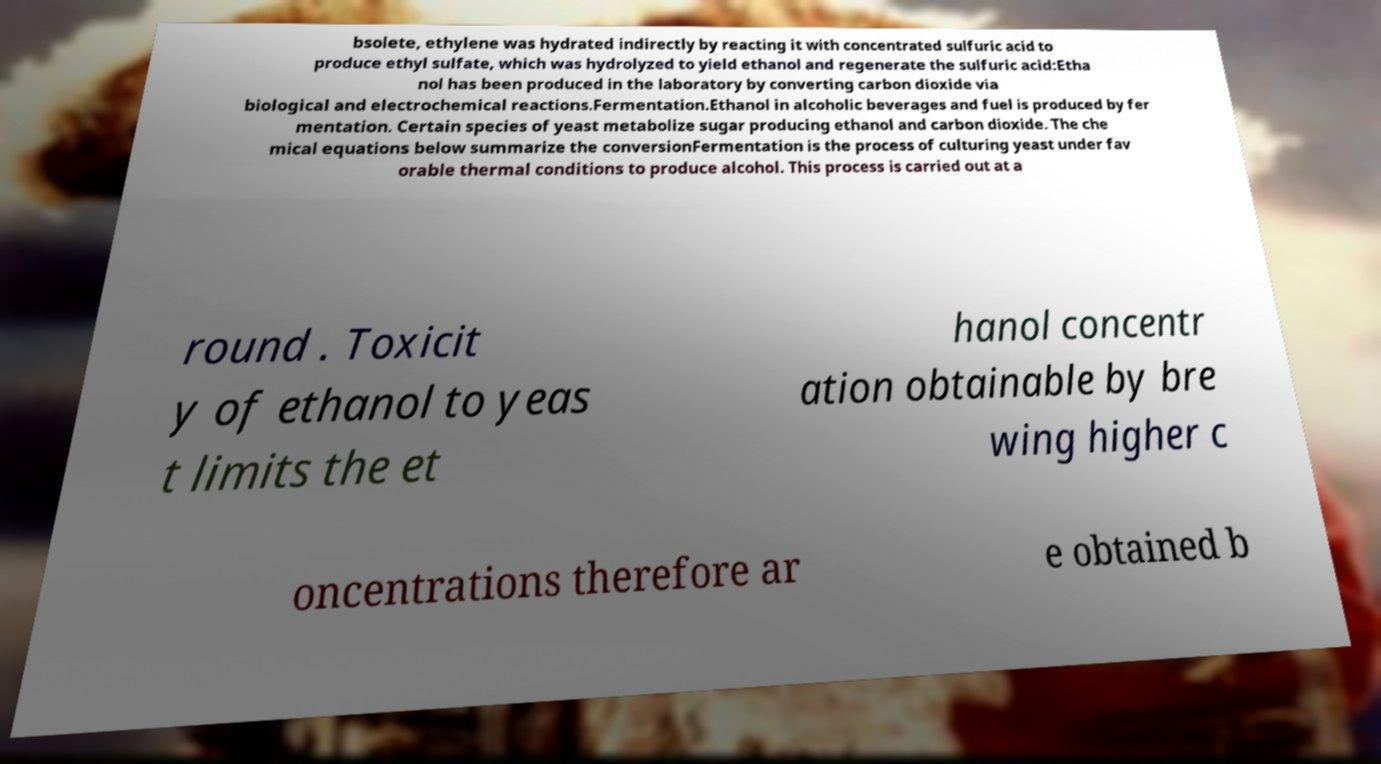There's text embedded in this image that I need extracted. Can you transcribe it verbatim? bsolete, ethylene was hydrated indirectly by reacting it with concentrated sulfuric acid to produce ethyl sulfate, which was hydrolyzed to yield ethanol and regenerate the sulfuric acid:Etha nol has been produced in the laboratory by converting carbon dioxide via biological and electrochemical reactions.Fermentation.Ethanol in alcoholic beverages and fuel is produced by fer mentation. Certain species of yeast metabolize sugar producing ethanol and carbon dioxide. The che mical equations below summarize the conversionFermentation is the process of culturing yeast under fav orable thermal conditions to produce alcohol. This process is carried out at a round . Toxicit y of ethanol to yeas t limits the et hanol concentr ation obtainable by bre wing higher c oncentrations therefore ar e obtained b 